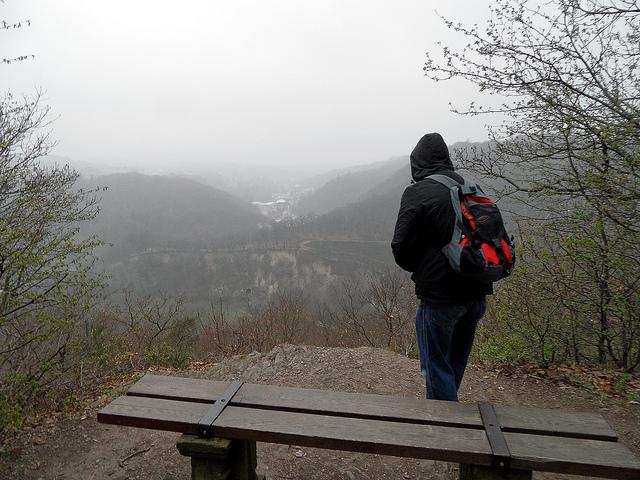What item here can hold the most books? backpack 